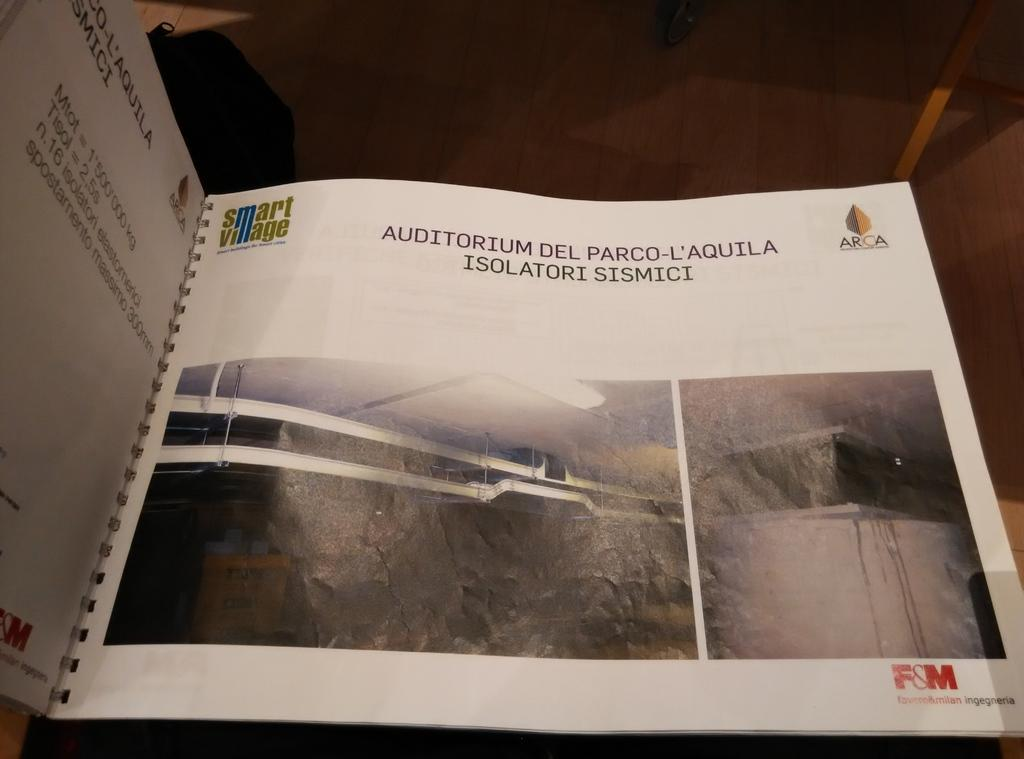<image>
Render a clear and concise summary of the photo. A book is open to the first page that says Smart Village. 